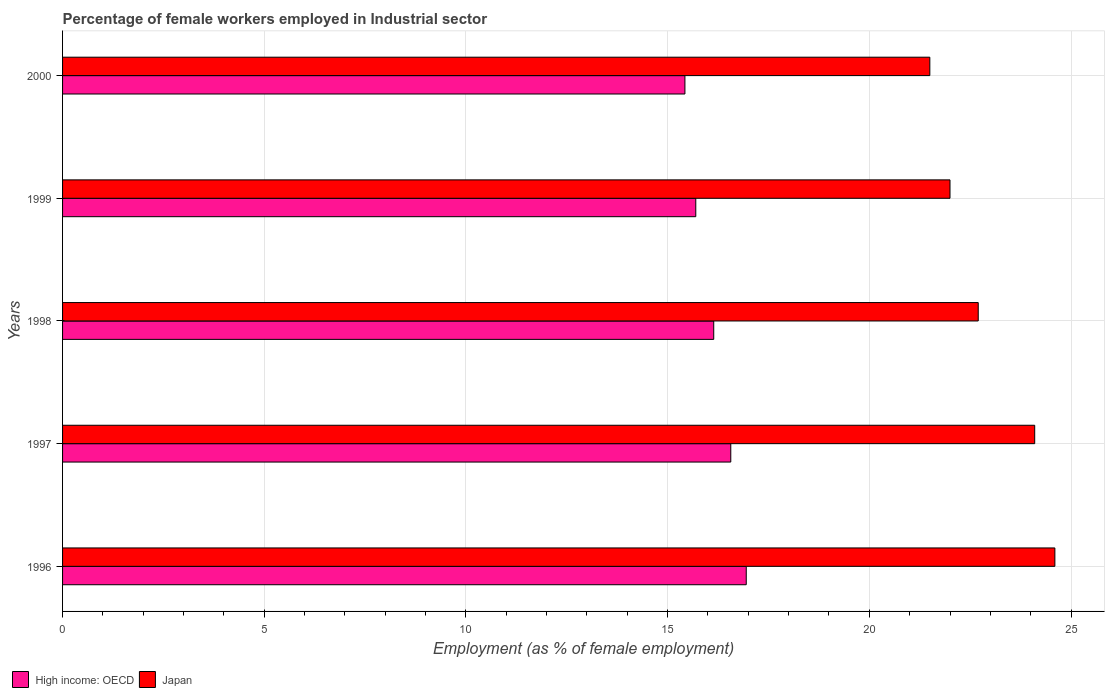How many different coloured bars are there?
Offer a very short reply. 2. How many groups of bars are there?
Make the answer very short. 5. What is the percentage of females employed in Industrial sector in Japan in 1999?
Give a very brief answer. 22. Across all years, what is the maximum percentage of females employed in Industrial sector in Japan?
Your response must be concise. 24.6. Across all years, what is the minimum percentage of females employed in Industrial sector in High income: OECD?
Give a very brief answer. 15.43. What is the total percentage of females employed in Industrial sector in Japan in the graph?
Provide a short and direct response. 114.9. What is the difference between the percentage of females employed in Industrial sector in Japan in 1998 and that in 1999?
Your answer should be very brief. 0.7. What is the difference between the percentage of females employed in Industrial sector in High income: OECD in 1998 and the percentage of females employed in Industrial sector in Japan in 1999?
Give a very brief answer. -5.86. What is the average percentage of females employed in Industrial sector in High income: OECD per year?
Make the answer very short. 16.16. In the year 1997, what is the difference between the percentage of females employed in Industrial sector in High income: OECD and percentage of females employed in Industrial sector in Japan?
Ensure brevity in your answer.  -7.53. What is the ratio of the percentage of females employed in Industrial sector in Japan in 1999 to that in 2000?
Keep it short and to the point. 1.02. What is the difference between the highest and the lowest percentage of females employed in Industrial sector in Japan?
Your answer should be compact. 3.1. Is the sum of the percentage of females employed in Industrial sector in High income: OECD in 1996 and 1998 greater than the maximum percentage of females employed in Industrial sector in Japan across all years?
Provide a succinct answer. Yes. What does the 1st bar from the top in 1996 represents?
Your answer should be compact. Japan. What does the 1st bar from the bottom in 1999 represents?
Keep it short and to the point. High income: OECD. How many bars are there?
Provide a short and direct response. 10. Are the values on the major ticks of X-axis written in scientific E-notation?
Provide a succinct answer. No. Where does the legend appear in the graph?
Provide a succinct answer. Bottom left. How many legend labels are there?
Give a very brief answer. 2. What is the title of the graph?
Provide a succinct answer. Percentage of female workers employed in Industrial sector. Does "Fiji" appear as one of the legend labels in the graph?
Offer a terse response. No. What is the label or title of the X-axis?
Make the answer very short. Employment (as % of female employment). What is the label or title of the Y-axis?
Provide a succinct answer. Years. What is the Employment (as % of female employment) of High income: OECD in 1996?
Offer a terse response. 16.95. What is the Employment (as % of female employment) in Japan in 1996?
Your answer should be very brief. 24.6. What is the Employment (as % of female employment) of High income: OECD in 1997?
Give a very brief answer. 16.57. What is the Employment (as % of female employment) of Japan in 1997?
Your response must be concise. 24.1. What is the Employment (as % of female employment) of High income: OECD in 1998?
Your answer should be very brief. 16.14. What is the Employment (as % of female employment) in Japan in 1998?
Make the answer very short. 22.7. What is the Employment (as % of female employment) of High income: OECD in 1999?
Give a very brief answer. 15.7. What is the Employment (as % of female employment) in High income: OECD in 2000?
Your answer should be compact. 15.43. Across all years, what is the maximum Employment (as % of female employment) of High income: OECD?
Make the answer very short. 16.95. Across all years, what is the maximum Employment (as % of female employment) of Japan?
Ensure brevity in your answer.  24.6. Across all years, what is the minimum Employment (as % of female employment) of High income: OECD?
Provide a short and direct response. 15.43. Across all years, what is the minimum Employment (as % of female employment) of Japan?
Provide a short and direct response. 21.5. What is the total Employment (as % of female employment) of High income: OECD in the graph?
Provide a succinct answer. 80.78. What is the total Employment (as % of female employment) in Japan in the graph?
Make the answer very short. 114.9. What is the difference between the Employment (as % of female employment) of High income: OECD in 1996 and that in 1997?
Keep it short and to the point. 0.38. What is the difference between the Employment (as % of female employment) in Japan in 1996 and that in 1997?
Provide a succinct answer. 0.5. What is the difference between the Employment (as % of female employment) in High income: OECD in 1996 and that in 1998?
Provide a succinct answer. 0.81. What is the difference between the Employment (as % of female employment) in Japan in 1996 and that in 1998?
Your answer should be very brief. 1.9. What is the difference between the Employment (as % of female employment) of High income: OECD in 1996 and that in 1999?
Offer a terse response. 1.25. What is the difference between the Employment (as % of female employment) in Japan in 1996 and that in 1999?
Offer a very short reply. 2.6. What is the difference between the Employment (as % of female employment) in High income: OECD in 1996 and that in 2000?
Your response must be concise. 1.52. What is the difference between the Employment (as % of female employment) of High income: OECD in 1997 and that in 1998?
Offer a very short reply. 0.42. What is the difference between the Employment (as % of female employment) of Japan in 1997 and that in 1998?
Offer a very short reply. 1.4. What is the difference between the Employment (as % of female employment) of High income: OECD in 1997 and that in 1999?
Your answer should be compact. 0.87. What is the difference between the Employment (as % of female employment) in Japan in 1997 and that in 1999?
Ensure brevity in your answer.  2.1. What is the difference between the Employment (as % of female employment) of High income: OECD in 1997 and that in 2000?
Your answer should be compact. 1.14. What is the difference between the Employment (as % of female employment) of Japan in 1997 and that in 2000?
Provide a succinct answer. 2.6. What is the difference between the Employment (as % of female employment) in High income: OECD in 1998 and that in 1999?
Offer a terse response. 0.45. What is the difference between the Employment (as % of female employment) of High income: OECD in 1998 and that in 2000?
Make the answer very short. 0.71. What is the difference between the Employment (as % of female employment) in Japan in 1998 and that in 2000?
Keep it short and to the point. 1.2. What is the difference between the Employment (as % of female employment) in High income: OECD in 1999 and that in 2000?
Make the answer very short. 0.27. What is the difference between the Employment (as % of female employment) in Japan in 1999 and that in 2000?
Your answer should be compact. 0.5. What is the difference between the Employment (as % of female employment) in High income: OECD in 1996 and the Employment (as % of female employment) in Japan in 1997?
Your response must be concise. -7.15. What is the difference between the Employment (as % of female employment) of High income: OECD in 1996 and the Employment (as % of female employment) of Japan in 1998?
Your answer should be very brief. -5.75. What is the difference between the Employment (as % of female employment) in High income: OECD in 1996 and the Employment (as % of female employment) in Japan in 1999?
Give a very brief answer. -5.05. What is the difference between the Employment (as % of female employment) of High income: OECD in 1996 and the Employment (as % of female employment) of Japan in 2000?
Keep it short and to the point. -4.55. What is the difference between the Employment (as % of female employment) of High income: OECD in 1997 and the Employment (as % of female employment) of Japan in 1998?
Keep it short and to the point. -6.13. What is the difference between the Employment (as % of female employment) in High income: OECD in 1997 and the Employment (as % of female employment) in Japan in 1999?
Give a very brief answer. -5.43. What is the difference between the Employment (as % of female employment) of High income: OECD in 1997 and the Employment (as % of female employment) of Japan in 2000?
Keep it short and to the point. -4.93. What is the difference between the Employment (as % of female employment) of High income: OECD in 1998 and the Employment (as % of female employment) of Japan in 1999?
Your answer should be compact. -5.86. What is the difference between the Employment (as % of female employment) in High income: OECD in 1998 and the Employment (as % of female employment) in Japan in 2000?
Ensure brevity in your answer.  -5.36. What is the difference between the Employment (as % of female employment) of High income: OECD in 1999 and the Employment (as % of female employment) of Japan in 2000?
Keep it short and to the point. -5.8. What is the average Employment (as % of female employment) in High income: OECD per year?
Provide a short and direct response. 16.16. What is the average Employment (as % of female employment) of Japan per year?
Your answer should be very brief. 22.98. In the year 1996, what is the difference between the Employment (as % of female employment) of High income: OECD and Employment (as % of female employment) of Japan?
Offer a very short reply. -7.65. In the year 1997, what is the difference between the Employment (as % of female employment) of High income: OECD and Employment (as % of female employment) of Japan?
Keep it short and to the point. -7.53. In the year 1998, what is the difference between the Employment (as % of female employment) of High income: OECD and Employment (as % of female employment) of Japan?
Offer a very short reply. -6.56. In the year 1999, what is the difference between the Employment (as % of female employment) in High income: OECD and Employment (as % of female employment) in Japan?
Make the answer very short. -6.3. In the year 2000, what is the difference between the Employment (as % of female employment) in High income: OECD and Employment (as % of female employment) in Japan?
Your answer should be compact. -6.07. What is the ratio of the Employment (as % of female employment) in High income: OECD in 1996 to that in 1997?
Give a very brief answer. 1.02. What is the ratio of the Employment (as % of female employment) of Japan in 1996 to that in 1997?
Offer a terse response. 1.02. What is the ratio of the Employment (as % of female employment) of High income: OECD in 1996 to that in 1998?
Provide a short and direct response. 1.05. What is the ratio of the Employment (as % of female employment) in Japan in 1996 to that in 1998?
Your answer should be very brief. 1.08. What is the ratio of the Employment (as % of female employment) of High income: OECD in 1996 to that in 1999?
Ensure brevity in your answer.  1.08. What is the ratio of the Employment (as % of female employment) of Japan in 1996 to that in 1999?
Keep it short and to the point. 1.12. What is the ratio of the Employment (as % of female employment) of High income: OECD in 1996 to that in 2000?
Your response must be concise. 1.1. What is the ratio of the Employment (as % of female employment) of Japan in 1996 to that in 2000?
Your answer should be compact. 1.14. What is the ratio of the Employment (as % of female employment) in High income: OECD in 1997 to that in 1998?
Ensure brevity in your answer.  1.03. What is the ratio of the Employment (as % of female employment) of Japan in 1997 to that in 1998?
Keep it short and to the point. 1.06. What is the ratio of the Employment (as % of female employment) of High income: OECD in 1997 to that in 1999?
Give a very brief answer. 1.06. What is the ratio of the Employment (as % of female employment) in Japan in 1997 to that in 1999?
Give a very brief answer. 1.1. What is the ratio of the Employment (as % of female employment) in High income: OECD in 1997 to that in 2000?
Your answer should be very brief. 1.07. What is the ratio of the Employment (as % of female employment) of Japan in 1997 to that in 2000?
Your answer should be compact. 1.12. What is the ratio of the Employment (as % of female employment) in High income: OECD in 1998 to that in 1999?
Make the answer very short. 1.03. What is the ratio of the Employment (as % of female employment) in Japan in 1998 to that in 1999?
Keep it short and to the point. 1.03. What is the ratio of the Employment (as % of female employment) of High income: OECD in 1998 to that in 2000?
Your answer should be compact. 1.05. What is the ratio of the Employment (as % of female employment) of Japan in 1998 to that in 2000?
Your response must be concise. 1.06. What is the ratio of the Employment (as % of female employment) of High income: OECD in 1999 to that in 2000?
Ensure brevity in your answer.  1.02. What is the ratio of the Employment (as % of female employment) in Japan in 1999 to that in 2000?
Your answer should be very brief. 1.02. What is the difference between the highest and the second highest Employment (as % of female employment) in High income: OECD?
Your answer should be very brief. 0.38. What is the difference between the highest and the lowest Employment (as % of female employment) of High income: OECD?
Provide a succinct answer. 1.52. What is the difference between the highest and the lowest Employment (as % of female employment) of Japan?
Offer a terse response. 3.1. 